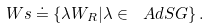Convert formula to latex. <formula><loc_0><loc_0><loc_500><loc_500>\ W s \doteq \{ \lambda W _ { R } | \lambda \in \ A d S G \} \, .</formula> 